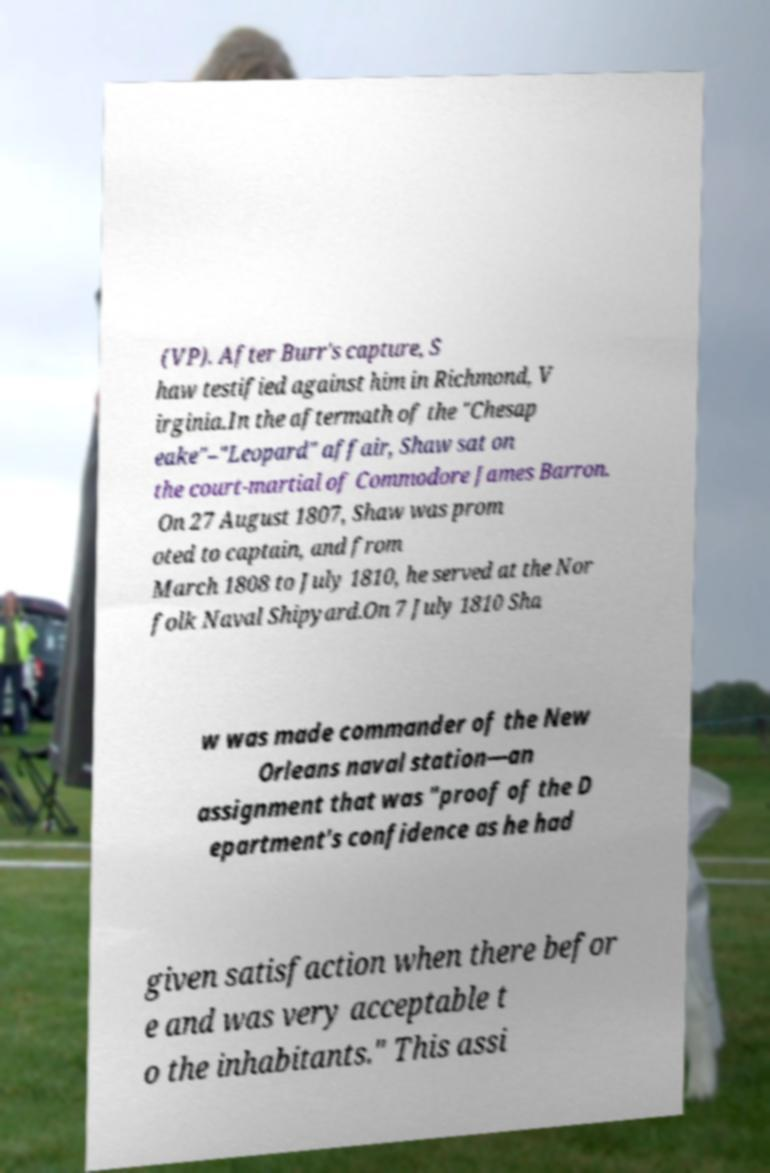There's text embedded in this image that I need extracted. Can you transcribe it verbatim? (VP). After Burr's capture, S haw testified against him in Richmond, V irginia.In the aftermath of the "Chesap eake"–"Leopard" affair, Shaw sat on the court-martial of Commodore James Barron. On 27 August 1807, Shaw was prom oted to captain, and from March 1808 to July 1810, he served at the Nor folk Naval Shipyard.On 7 July 1810 Sha w was made commander of the New Orleans naval station—an assignment that was "proof of the D epartment's confidence as he had given satisfaction when there befor e and was very acceptable t o the inhabitants." This assi 